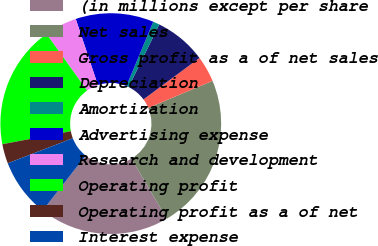<chart> <loc_0><loc_0><loc_500><loc_500><pie_chart><fcel>(in millions except per share<fcel>Net sales<fcel>Gross profit as a of net sales<fcel>Depreciation<fcel>Amortization<fcel>Advertising expense<fcel>Research and development<fcel>Operating profit<fcel>Operating profit as a of net<fcel>Interest expense<nl><fcel>19.05%<fcel>22.86%<fcel>3.81%<fcel>7.62%<fcel>0.95%<fcel>11.43%<fcel>4.76%<fcel>18.09%<fcel>2.86%<fcel>8.57%<nl></chart> 